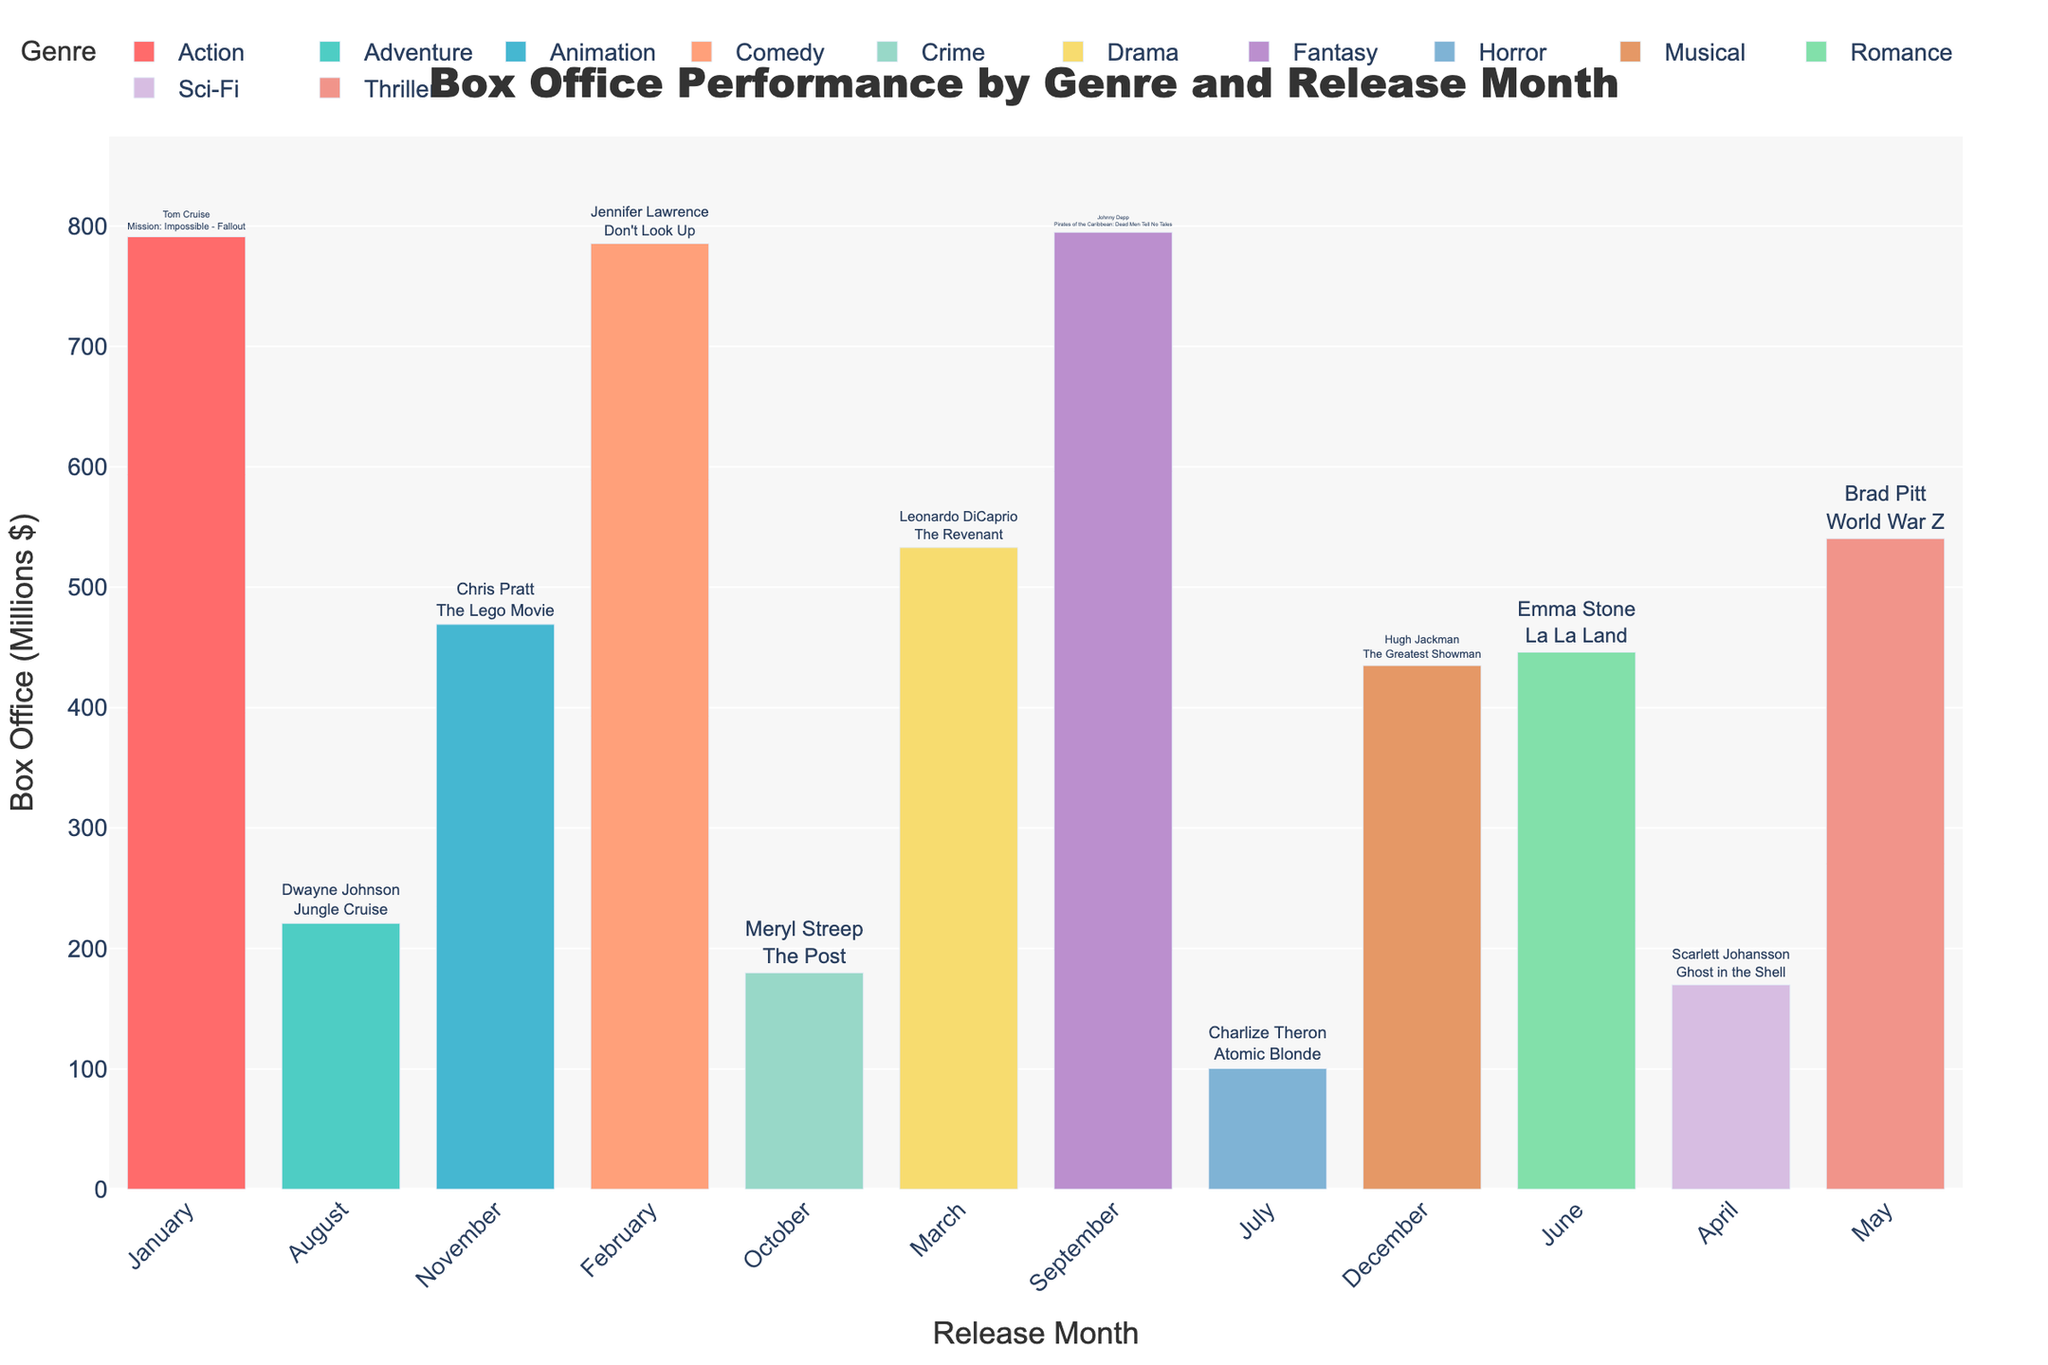What's the title of the figure? The title is displayed at the top-center of the figure, typically in a larger and bolder font compared to other text elements. The title is "Box Office Performance by Genre and Release Month".
Answer: Box Office Performance by Genre and Release Month Which genre has the highest box office performance? By looking at the height of the bars in the plot, the genre with the tallest bar indicates the highest box office performance. The "Fantasy" genre has the highest bar with $794.9 million for the movie "Pirates of the Caribbean: Dead Men Tell No Tales".
Answer: Fantasy In which month did Jennifer Lawrence's movie perform? Each genre's performance is broken down by release month, depicted on the x-axis. By hovering over the "Comedy" genre, or by identifying February, we observe that "Don't Look Up" is listed under Jennifer Lawrence with a box office of $785.5 million.
Answer: February What is the combined box office performance of the top two genres? The highest box office performance is the "Fantasy" genre with $794.9 million. The second highest is the "Action" genre with $791.1 million for "Mission: Impossible - Fallout". Summing them up gives $794.9 million + $791.1 million = $1586.0 million.
Answer: $1586.0 million Which movie had the lowest box office performance and who was the starring celebrity? To find the lowest performance, we look at the shortest bar in the plot. The "Horror" genre has the lowest bar, representing a box office performance of $100.3 million. The movie is "Atomic Blonde" starring Charlize Theron.
Answer: Atomic Blonde, Charlize Theron Which genre has the most number of A-list celebrity performers in different months? By counting the number of unique months for each genre, we can determine which genre features the most A-list celebrities. Each genre appears only once across the different months. Thus, each has one feature.
Answer: Tie (all categories have 1) How does the box office performance of "La La Land" compare to that of "The Greatest Showman"? By locating the bars for "Romance" and "Musical" genres and comparing their heights, "La La Land" has a performance of $446.1 million while "The Greatest Showman" has $435.0 million, which makes "La La Land" slightly higher.
Answer: La La Land is higher What's the average box office performance across all genres? To compute the average, we sum the box office values for all movies and divide by the number of movies. The total is $791.1M + $785.5M + $533.0M + $169.8M + $540.5M + $446.1M + $100.3M + $220.9M + $794.9M + $179.8M + $469.2M + $435.0M = $5465.9M. There are 12 movies, so $5465.9M / 12 ≈ $455.5M.
Answer: $455.5 million 